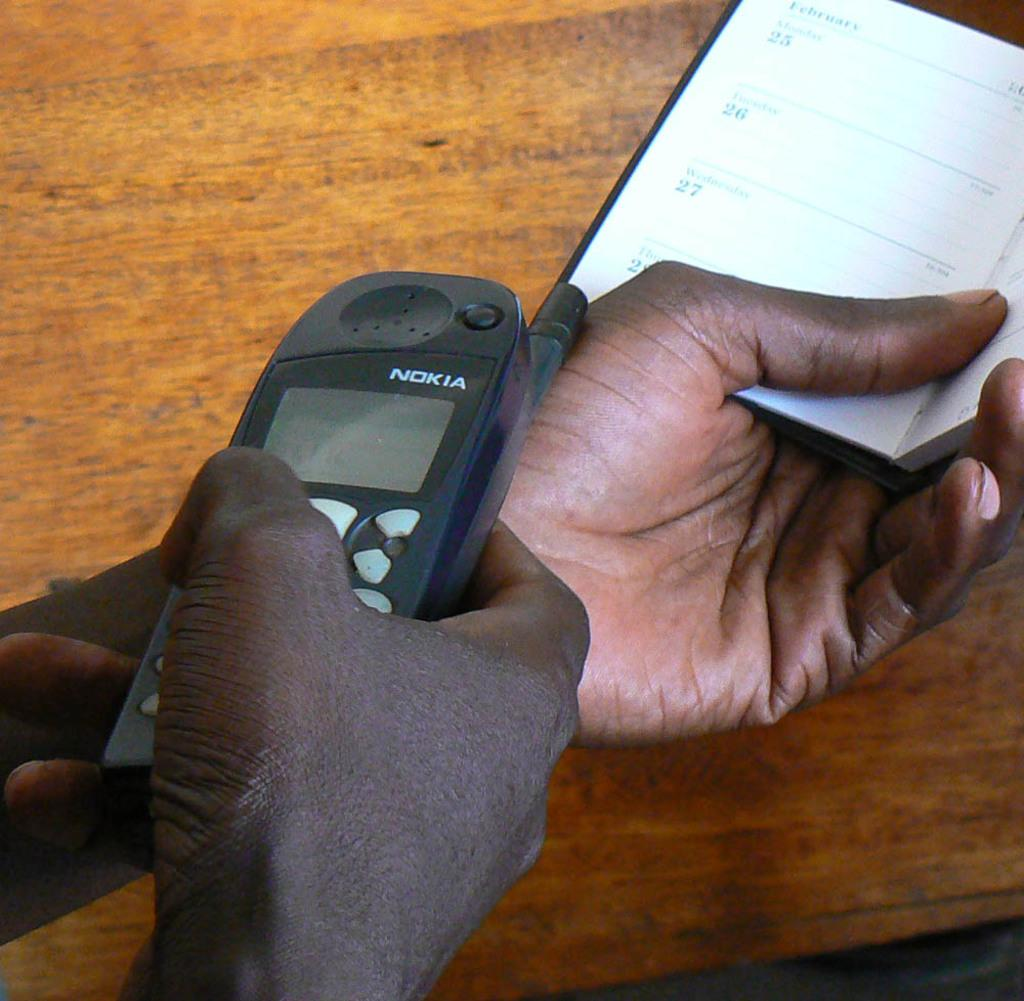<image>
Give a short and clear explanation of the subsequent image. A man holds a calendar in one hand and dials a Nokia phone with the other hand. 